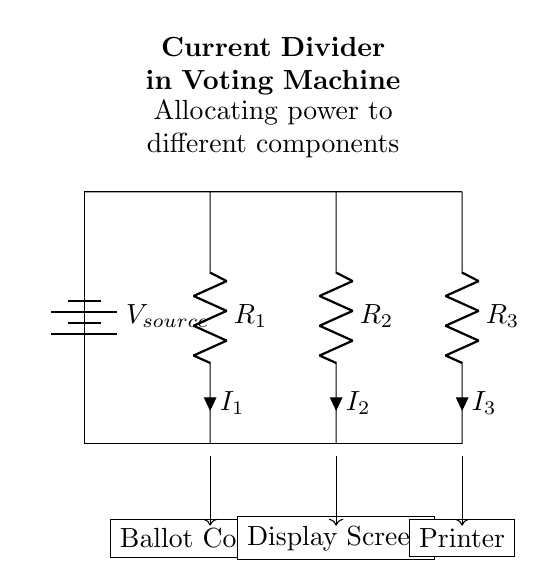What are the components of the current divider? The components shown are a battery, three resistors labeled as R1, R2, and R3, and three devices: a ballot counter, a display screen, and a printer.
Answer: Battery, R1, R2, R3, ballot counter, display screen, printer What is the purpose of the current divider in the voting machine? The current divider allocates different amounts of current to each component (ballot counter, display screen, and printer) based on the resistance values of R1, R2, and R3.
Answer: Allocate current How many resistors are in the circuit? The diagram indicates the presence of three resistors: R1, R2, and R3, connected in parallel.
Answer: Three What is the current through the ballot counter (I1)? In a current divider, the current through a resistor is inversely proportional to its resistance. We look at its position in relation to R1 as well; this is specified when analyzing the circuit but details on values aren’t given.
Answer: I1 is dependent on R1 Which device receives the most current? To determine this, we need to consider the resistance; the device with the lowest resistance in parallel (the one with the lowest value of R) will receive the most current. Without specific values, we can’t calculate but assume it’s determined by the resistors' values.
Answer: Device with lowest R What does the arrow direction on the connections signify? The arrows indicate the direction of current flow towards each connected device (ballot counter, display screen, printer), showing where the current will deliver power.
Answer: Current flow direction How does resistance affect power allocation in this circuit? In a current divider, a lower resistance results in a higher current allocation to that branch because current divides inversely proportionally to resistance. Thus, components with lower resistance will consume more current.
Answer: Lower resistance = higher current 